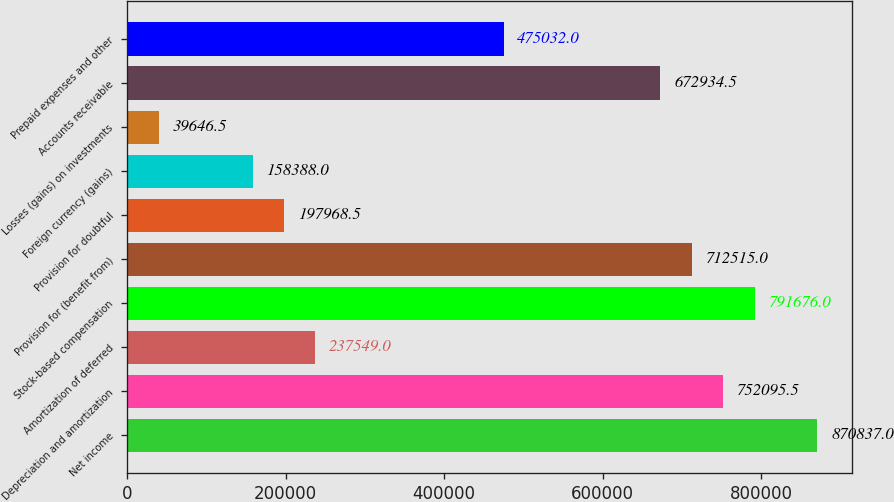Convert chart to OTSL. <chart><loc_0><loc_0><loc_500><loc_500><bar_chart><fcel>Net income<fcel>Depreciation and amortization<fcel>Amortization of deferred<fcel>Stock-based compensation<fcel>Provision for (benefit from)<fcel>Provision for doubtful<fcel>Foreign currency (gains)<fcel>Losses (gains) on investments<fcel>Accounts receivable<fcel>Prepaid expenses and other<nl><fcel>870837<fcel>752096<fcel>237549<fcel>791676<fcel>712515<fcel>197968<fcel>158388<fcel>39646.5<fcel>672934<fcel>475032<nl></chart> 